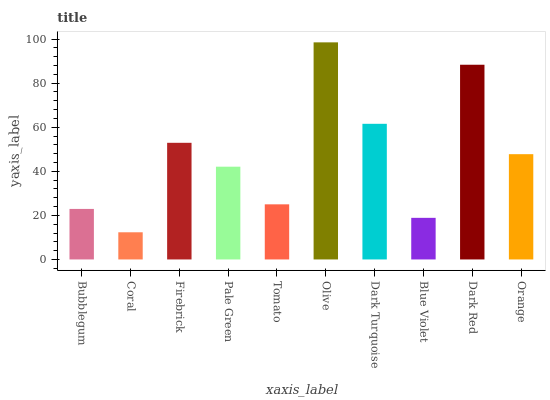Is Coral the minimum?
Answer yes or no. Yes. Is Olive the maximum?
Answer yes or no. Yes. Is Firebrick the minimum?
Answer yes or no. No. Is Firebrick the maximum?
Answer yes or no. No. Is Firebrick greater than Coral?
Answer yes or no. Yes. Is Coral less than Firebrick?
Answer yes or no. Yes. Is Coral greater than Firebrick?
Answer yes or no. No. Is Firebrick less than Coral?
Answer yes or no. No. Is Orange the high median?
Answer yes or no. Yes. Is Pale Green the low median?
Answer yes or no. Yes. Is Coral the high median?
Answer yes or no. No. Is Dark Turquoise the low median?
Answer yes or no. No. 